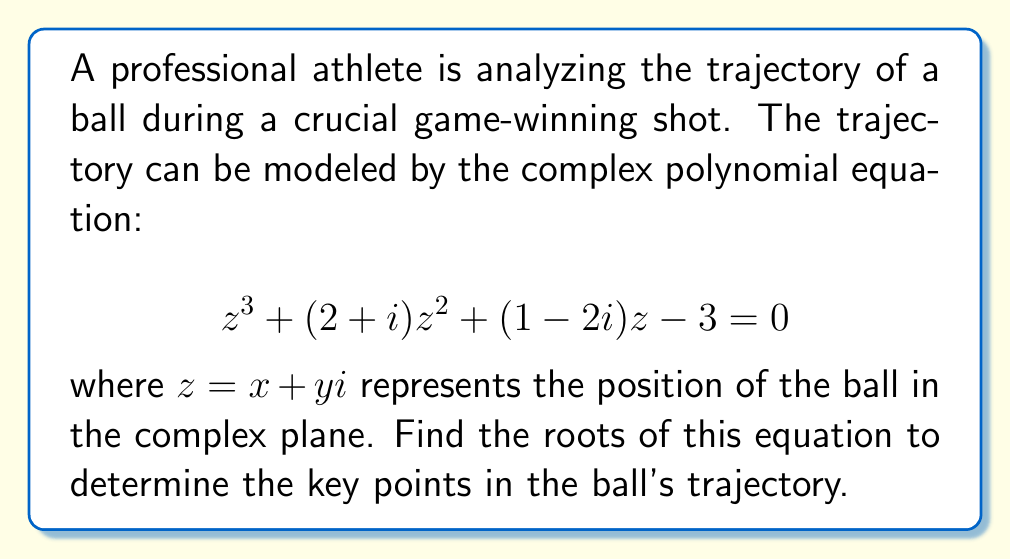Solve this math problem. To find the roots of the complex polynomial equation, we'll use the following steps:

1) First, we need to recognize that this is a cubic equation of the form $az^3 + bz^2 + cz + d = 0$, where:
   $a = 1$
   $b = 2+i$
   $c = 1-2i$
   $d = -3$

2) For cubic equations, we can use Cardano's formula. Let's define:
   $$p = \frac{3ac-b^2}{3a^2}$$
   $$q = \frac{2b^3-9abc+27a^2d}{27a^3}$$

3) Calculating $p$:
   $$p = \frac{3(1)(1-2i)-(2+i)^2}{3(1)^2} = \frac{3-6i-(4+4i+i^2)}{3} = \frac{3-6i-(4+4i-1)}{3} = \frac{-2i}{3}$$

4) Calculating $q$:
   $$q = \frac{2(2+i)^3-9(1)(2+i)(1-2i)+27(1)^2(-3)}{27(1)^3}$$
   $$= \frac{2(8+12i-1)-9(2+i-4i-2i^2)-81}{27}$$
   $$= \frac{14+24i-9(2-3i+2)-81}{27} = \frac{14+24i-18+27i-18-81}{27} = \frac{-103+51i}{27}$$

5) Now, we define:
   $$u = \sqrt[3]{-\frac{q}{2} + \sqrt{\frac{q^2}{4} + \frac{p^3}{27}}}$$
   $$v = \sqrt[3]{-\frac{q}{2} - \sqrt{\frac{q^2}{4} + \frac{p^3}{27}}}$$

6) Calculating $u$ and $v$:
   $$u = \sqrt[3]{\frac{103-51i}{54} + \sqrt{\frac{(103-51i)^2}{2916} + \frac{(-2i)^3}{729}}} \approx 1.4422 - 0.1952i$$
   $$v = \sqrt[3]{\frac{103-51i}{54} - \sqrt{\frac{(103-51i)^2}{2916} + \frac{(-2i)^3}{729}}} \approx -0.7211 + 0.0976i$$

7) The roots are given by:
   $$z_1 = u + v - \frac{b}{3a}$$
   $$z_2 = -\frac{u+v}{2} - \frac{b}{3a} + i\frac{\sqrt{3}}{2}(u-v)$$
   $$z_3 = -\frac{u+v}{2} - \frac{b}{3a} - i\frac{\sqrt{3}}{2}(u-v)$$

8) Substituting the values:
   $$z_1 \approx 1.4422 - 0.1952i - 0.7211 + 0.0976i - \frac{2+i}{3} \approx 0.0545 - 0.4309i$$
   $$z_2 \approx -0.3606 + 0.0488i - \frac{2+i}{3} + i(1.2472)(2.1633 - 0.2928i) \approx -1.0273 + 1.7155i$$
   $$z_3 \approx -0.3606 + 0.0488i - \frac{2+i}{3} - i(1.2472)(2.1633 - 0.2928i) \approx -1.0273 - 1.7155i$$
Answer: $z_1 \approx 0.0545 - 0.4309i$, $z_2 \approx -1.0273 + 1.7155i$, $z_3 \approx -1.0273 - 1.7155i$ 